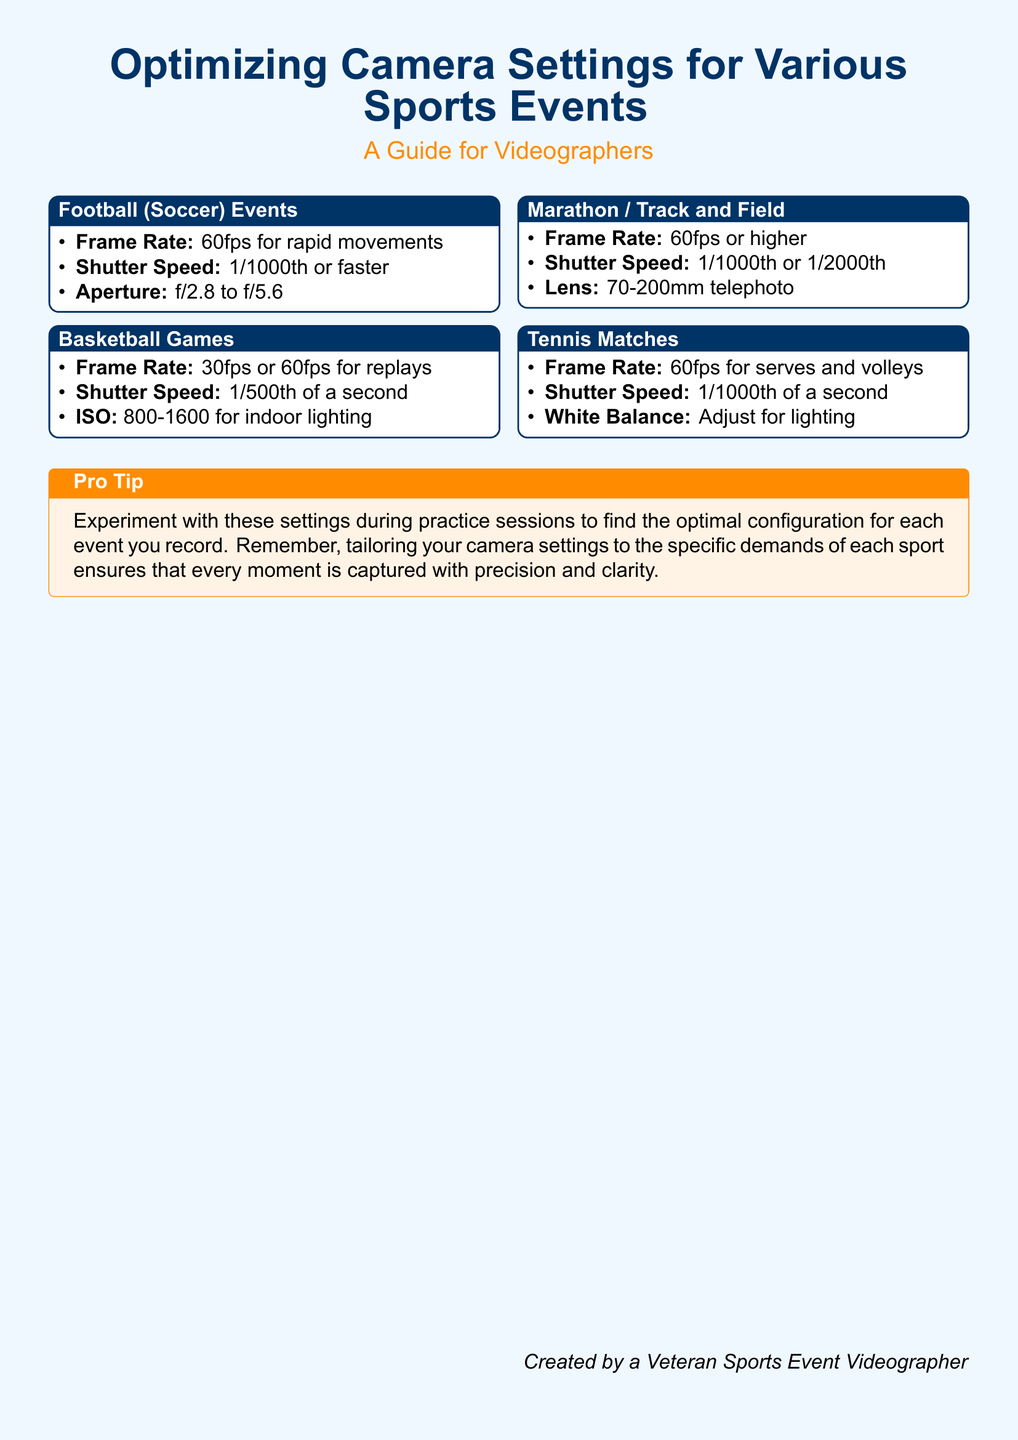What is the recommended frame rate for football events? The recommended frame rate for football events is specified to be 60fps for rapid movements.
Answer: 60fps What is the shutter speed for basketball games? The document states that the shutter speed for basketball games is 1/500th of a second.
Answer: 1/500th of a second What ISO range is suggested for indoor basketball lighting? It indicates an ISO range of 800-1600 for indoor lighting during basketball games.
Answer: 800-1600 What lens is recommended for marathon and track and field events? The document suggests using a 70-200mm telephoto lens for marathon and track and field events.
Answer: 70-200mm telephoto What is a pro tip mentioned in the document? The document advises to experiment with settings during practice sessions to find the optimal configuration for each event.
Answer: Experiment with these settings during practice sessions What shutter speed is recommended for tennis matches? The recommended shutter speed for tennis matches is 1/1000th of a second.
Answer: 1/1000th of a second What frame rate is ideal for capturing serves and volleys in tennis? It specifies a frame rate of 60fps for serves and volleys in tennis matches.
Answer: 60fps What is the impact of tailoring camera settings according to sport? Tailoring camera settings to the specific demands ensures that every moment is captured with precision and clarity.
Answer: Precision and clarity 